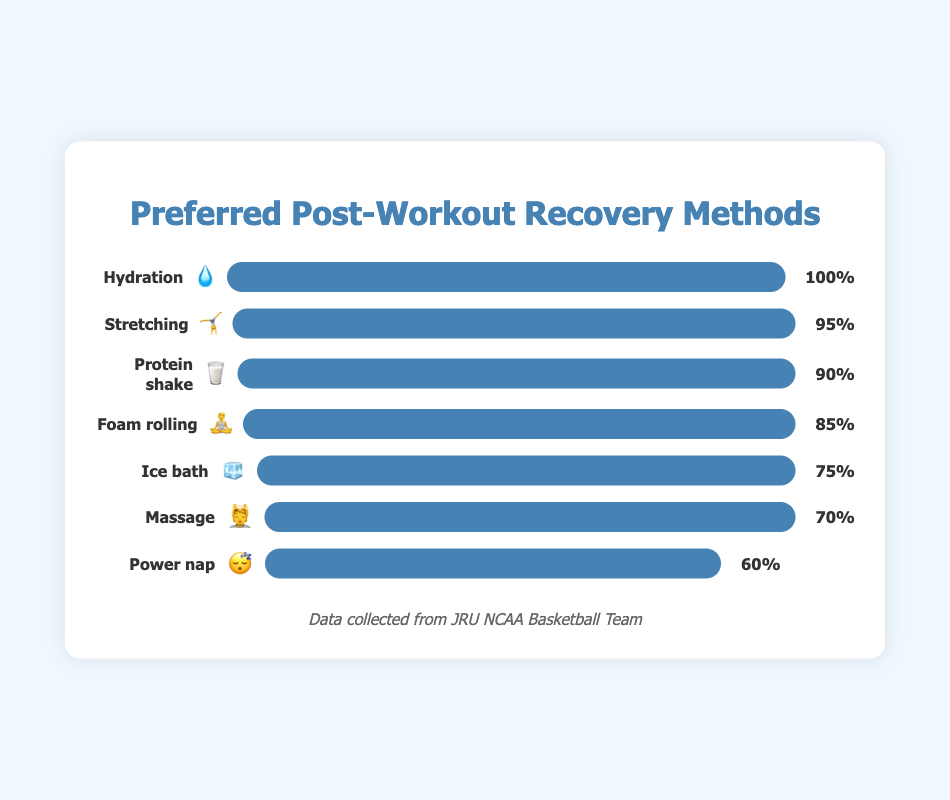What is the most preferred post-workout recovery method among student-athletes? The chart lists various recovery methods along with their popularity percentage. The most preferred method is the one with the highest popularity percentage.
Answer: Hydration 💧 Which recovery method is least preferred and what is its popularity percentage? By examining the chart, the method with the smallest bar width corresponds to the least popular method.
Answer: Power nap 😴, 60% What is the combined popularity percentage of "Foam rolling" and "Protein shake"? The popularity percentage of "Foam rolling" is 85% and "Protein shake" is 90%. Adding these two percentages together gives 85 + 90 = 175%.
Answer: 175% How much more popular is "Hydration" compared to "Massage"? The popularity of "Hydration" is 100%, and the popularity of "Massage" is 70%. Subtracting the popularity of "Massage" from "Hydration" gives 100 - 70 = 30%.
Answer: 30% Rank the methods in descending order of their popularity. To rank the methods, list them from the highest to the lowest popularity percentage: Hydration (100%), Stretching (95%), Protein shake (90%), Foam rolling (85%), Ice bath (75%), Massage (70%), Power nap (60%)
Answer: Hydration 💧, Stretching 🤸, Protein shake 🥛, Foam rolling 🧘, Ice bath 🧊, Massage 💆, Power nap 😴 What is the average popularity percentage of all the recovery methods listed? The combined popularity percentage of all methods is 75 + 85 + 90 + 95 + 70 + 100 + 60 = 575%. There are 7 recovery methods, so the average is 575 ÷ 7 ≈ 82.14%.
Answer: 82.14% By how much does "Stretching" outperform "Ice bath" in terms of popularity percentage? The popularity of "Stretching" is 95%, and the popularity of "Ice bath" is 75%. Subtracting the popularity of "Ice bath" from "Stretching" gives 95 - 75 = 20%.
Answer: 20% Which recovery methods have a popularity percentage greater than 80%? By inspecting the chart, the methods that have a popularity percentage greater than 80% are "Foam rolling" (85%), "Protein shake" (90%), "Stretching" (95%), and "Hydration" (100%).
Answer: Foam rolling 🧘, Protein shake 🥛, Stretching 🤸, Hydration 💧 